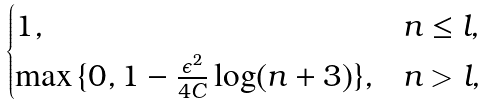<formula> <loc_0><loc_0><loc_500><loc_500>\begin{cases} 1 , & n \leq l , \\ \max \, \{ 0 , 1 - \frac { \epsilon ^ { 2 } } { 4 C } \log ( n + 3 ) \} , & n > l , \end{cases}</formula> 